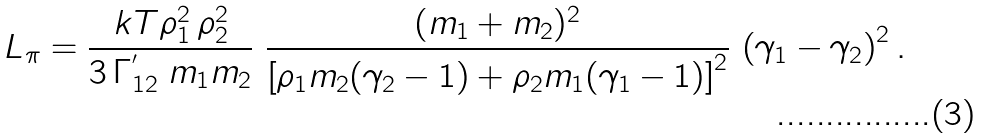<formula> <loc_0><loc_0><loc_500><loc_500>L _ { \pi } = \frac { k T \rho _ { 1 } ^ { 2 } \, \rho _ { 2 } ^ { 2 } } { 3 \, \Gamma _ { 1 2 } ^ { ^ { \prime } } \ m _ { 1 } m _ { 2 } } \ \frac { ( m _ { 1 } + m _ { 2 } ) ^ { 2 } } { \left [ \rho _ { 1 } m _ { 2 } ( \gamma _ { 2 } - 1 ) + \rho _ { 2 } m _ { 1 } ( \gamma _ { 1 } - 1 ) \right ] ^ { 2 } } \, \left ( \gamma _ { 1 } - \gamma _ { 2 } \right ) ^ { 2 } .</formula> 